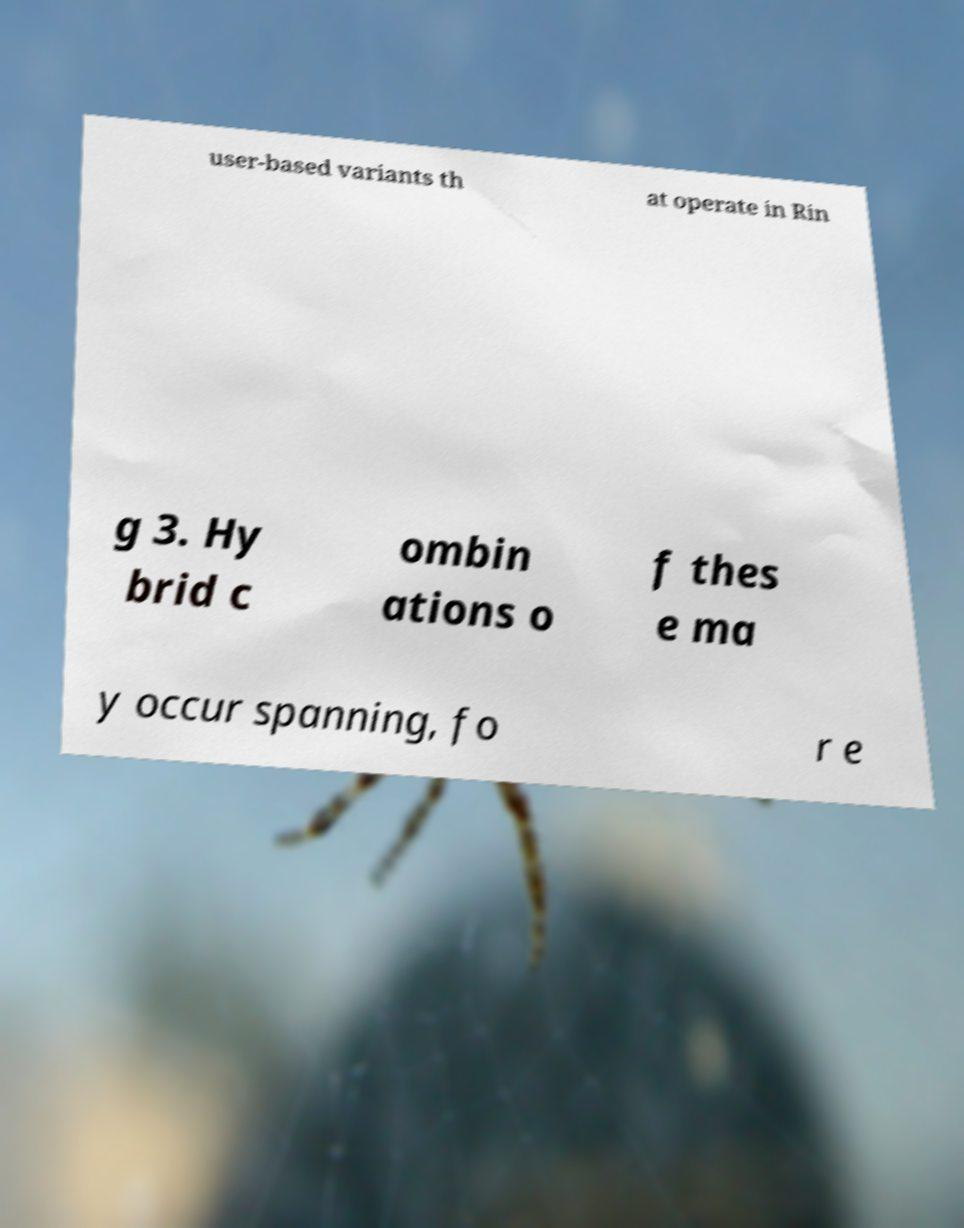Could you extract and type out the text from this image? user-based variants th at operate in Rin g 3. Hy brid c ombin ations o f thes e ma y occur spanning, fo r e 